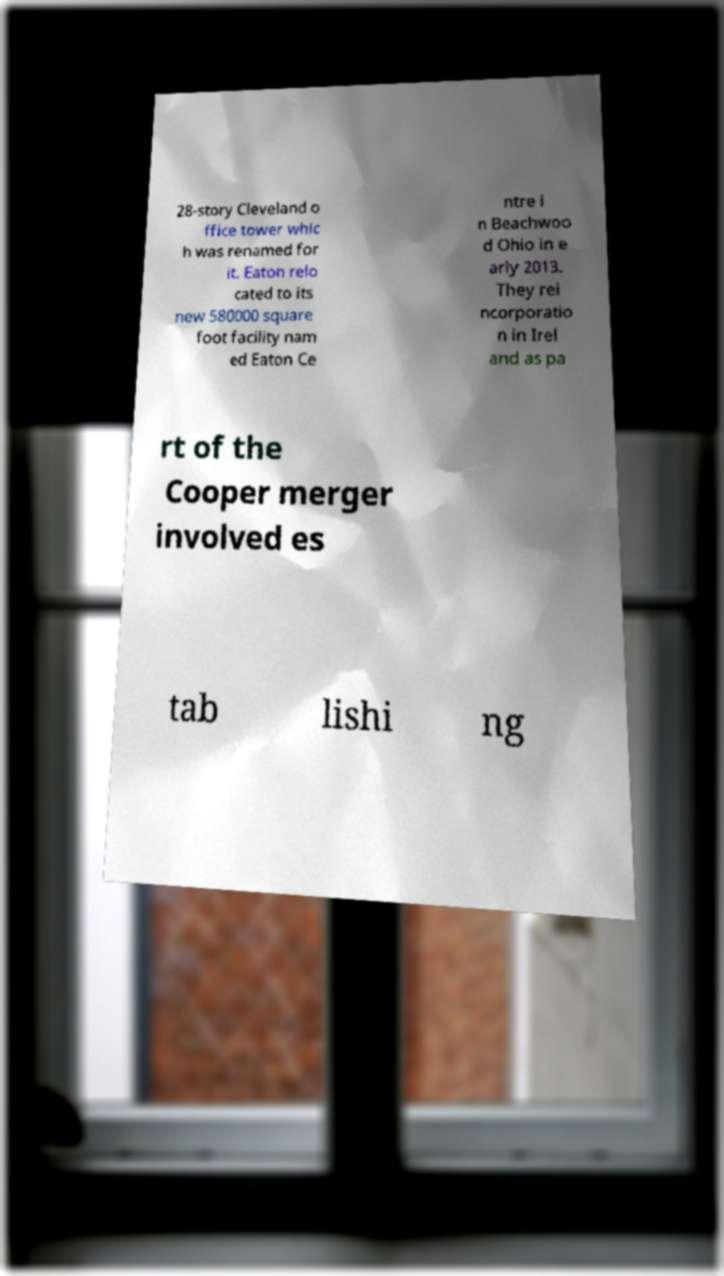There's text embedded in this image that I need extracted. Can you transcribe it verbatim? 28-story Cleveland o ffice tower whic h was renamed for it. Eaton relo cated to its new 580000 square foot facility nam ed Eaton Ce ntre i n Beachwoo d Ohio in e arly 2013. They rei ncorporatio n in Irel and as pa rt of the Cooper merger involved es tab lishi ng 